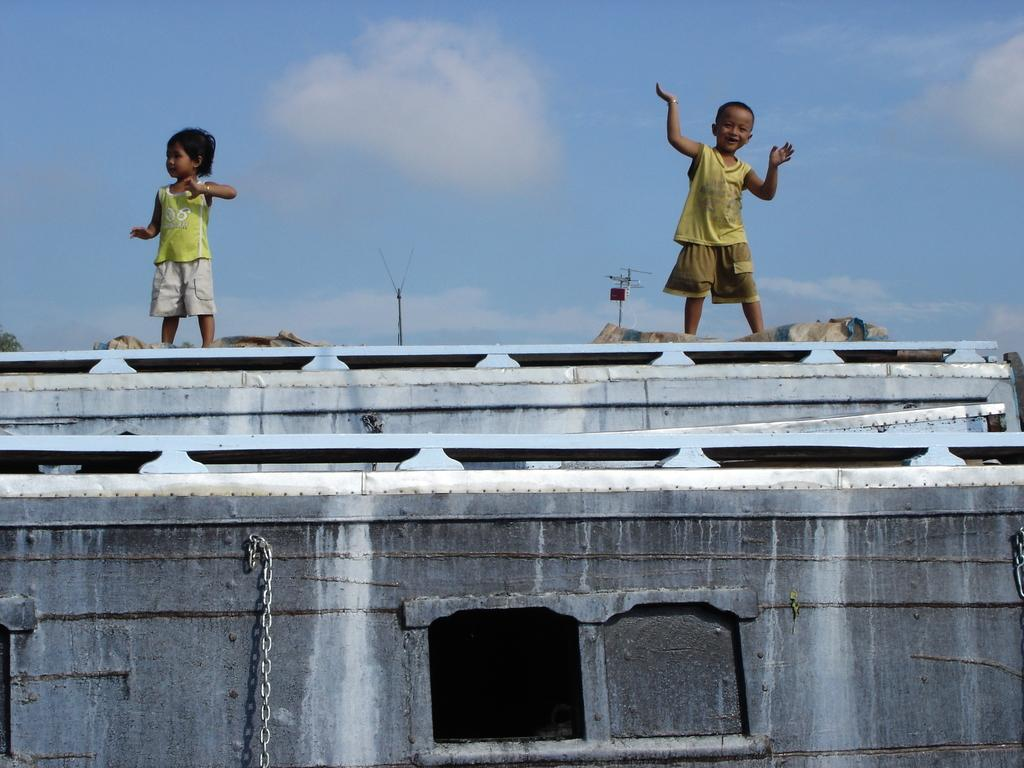What type of structure can be seen in the image? There is a wall in the image. Is there any opening in the wall? Yes, there is a window in the image. How many kids are visible in the image? There are two kids standing in the image. What is the color of the sky in the image? The sky is blue in the image. Are there any clouds visible in the sky? Yes, there are white clouds in the sky. What type of voice can be heard coming from the kids in the image? There is no sound or voice present in the image, as it is a still photograph. 